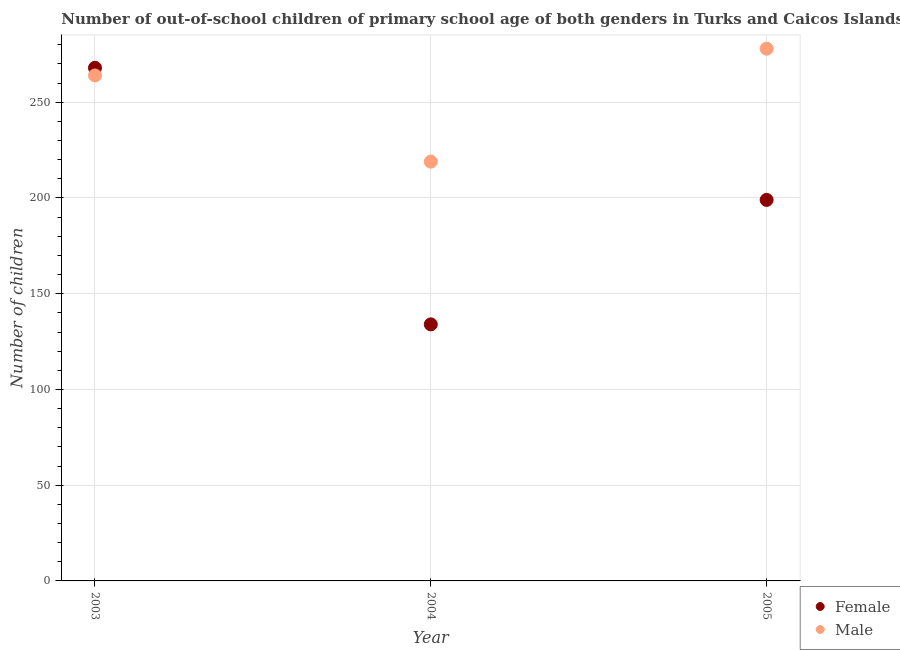How many different coloured dotlines are there?
Provide a succinct answer. 2. Is the number of dotlines equal to the number of legend labels?
Provide a succinct answer. Yes. What is the number of male out-of-school students in 2004?
Provide a short and direct response. 219. Across all years, what is the maximum number of male out-of-school students?
Give a very brief answer. 278. Across all years, what is the minimum number of male out-of-school students?
Keep it short and to the point. 219. In which year was the number of female out-of-school students maximum?
Offer a very short reply. 2003. In which year was the number of female out-of-school students minimum?
Provide a succinct answer. 2004. What is the total number of male out-of-school students in the graph?
Your response must be concise. 761. What is the difference between the number of female out-of-school students in 2004 and that in 2005?
Provide a succinct answer. -65. What is the difference between the number of female out-of-school students in 2003 and the number of male out-of-school students in 2004?
Offer a terse response. 49. What is the average number of male out-of-school students per year?
Your response must be concise. 253.67. In the year 2003, what is the difference between the number of male out-of-school students and number of female out-of-school students?
Ensure brevity in your answer.  -4. In how many years, is the number of male out-of-school students greater than 90?
Give a very brief answer. 3. What is the ratio of the number of male out-of-school students in 2003 to that in 2004?
Your answer should be compact. 1.21. Is the difference between the number of male out-of-school students in 2004 and 2005 greater than the difference between the number of female out-of-school students in 2004 and 2005?
Your answer should be very brief. Yes. What is the difference between the highest and the second highest number of female out-of-school students?
Keep it short and to the point. 69. What is the difference between the highest and the lowest number of female out-of-school students?
Give a very brief answer. 134. In how many years, is the number of female out-of-school students greater than the average number of female out-of-school students taken over all years?
Provide a succinct answer. 1. Does the number of female out-of-school students monotonically increase over the years?
Provide a succinct answer. No. Is the number of male out-of-school students strictly less than the number of female out-of-school students over the years?
Provide a short and direct response. No. How many years are there in the graph?
Offer a very short reply. 3. How many legend labels are there?
Ensure brevity in your answer.  2. What is the title of the graph?
Your answer should be compact. Number of out-of-school children of primary school age of both genders in Turks and Caicos Islands. What is the label or title of the X-axis?
Ensure brevity in your answer.  Year. What is the label or title of the Y-axis?
Give a very brief answer. Number of children. What is the Number of children of Female in 2003?
Keep it short and to the point. 268. What is the Number of children in Male in 2003?
Give a very brief answer. 264. What is the Number of children in Female in 2004?
Your response must be concise. 134. What is the Number of children in Male in 2004?
Provide a short and direct response. 219. What is the Number of children of Female in 2005?
Ensure brevity in your answer.  199. What is the Number of children of Male in 2005?
Your response must be concise. 278. Across all years, what is the maximum Number of children of Female?
Ensure brevity in your answer.  268. Across all years, what is the maximum Number of children of Male?
Provide a short and direct response. 278. Across all years, what is the minimum Number of children of Female?
Offer a terse response. 134. Across all years, what is the minimum Number of children of Male?
Offer a terse response. 219. What is the total Number of children of Female in the graph?
Your answer should be compact. 601. What is the total Number of children in Male in the graph?
Your response must be concise. 761. What is the difference between the Number of children in Female in 2003 and that in 2004?
Ensure brevity in your answer.  134. What is the difference between the Number of children of Male in 2003 and that in 2004?
Your answer should be compact. 45. What is the difference between the Number of children of Female in 2004 and that in 2005?
Your response must be concise. -65. What is the difference between the Number of children of Male in 2004 and that in 2005?
Make the answer very short. -59. What is the difference between the Number of children of Female in 2003 and the Number of children of Male in 2004?
Your response must be concise. 49. What is the difference between the Number of children in Female in 2004 and the Number of children in Male in 2005?
Offer a terse response. -144. What is the average Number of children in Female per year?
Your answer should be very brief. 200.33. What is the average Number of children in Male per year?
Provide a succinct answer. 253.67. In the year 2003, what is the difference between the Number of children of Female and Number of children of Male?
Make the answer very short. 4. In the year 2004, what is the difference between the Number of children in Female and Number of children in Male?
Your response must be concise. -85. In the year 2005, what is the difference between the Number of children of Female and Number of children of Male?
Keep it short and to the point. -79. What is the ratio of the Number of children in Male in 2003 to that in 2004?
Your response must be concise. 1.21. What is the ratio of the Number of children of Female in 2003 to that in 2005?
Make the answer very short. 1.35. What is the ratio of the Number of children in Male in 2003 to that in 2005?
Your response must be concise. 0.95. What is the ratio of the Number of children of Female in 2004 to that in 2005?
Make the answer very short. 0.67. What is the ratio of the Number of children of Male in 2004 to that in 2005?
Provide a succinct answer. 0.79. What is the difference between the highest and the lowest Number of children of Female?
Offer a very short reply. 134. 